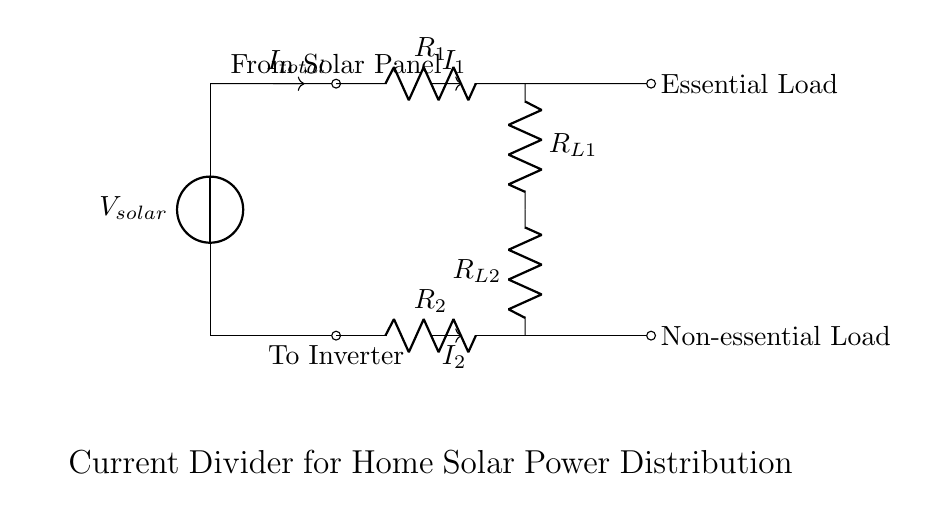What is the total current entering the current divider? The total current entering the current divider is represented as I total, which is shown in the circuit diagram.
Answer: I total What are the load types connected to the current divider? The circuit diagram specifies two types of loads connected to the current divider: Essential Load and Non-essential Load.
Answer: Essential Load and Non-essential Load What resistors are part of the current divider? The current divider consists of two resistors labeled R1 and R2, which manage the division of current.
Answer: R1 and R2 How does the current divide between the two loads? The current divides based on the resistance values of R1 and R2. According to the current divider rule, the current will be inversely proportional to the resistance in each branch. This means that the load with the lower resistance will receive a higher portion of the total current.
Answer: Based on resistance values What is the purpose of the current divider in this solar setup? The purpose of the current divider in this context is to distribute the total current generated by the solar panel to the essential and non-essential loads efficiently, allowing for proper power management within the home solar panel setup.
Answer: Distribute total current 